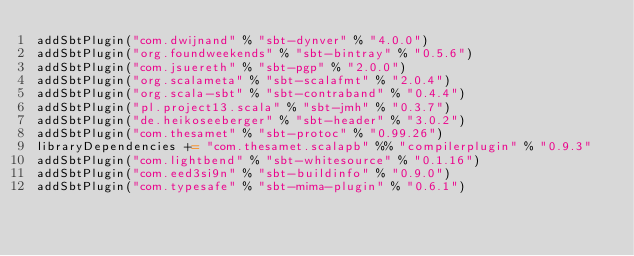Convert code to text. <code><loc_0><loc_0><loc_500><loc_500><_Scala_>addSbtPlugin("com.dwijnand" % "sbt-dynver" % "4.0.0")
addSbtPlugin("org.foundweekends" % "sbt-bintray" % "0.5.6")
addSbtPlugin("com.jsuereth" % "sbt-pgp" % "2.0.0")
addSbtPlugin("org.scalameta" % "sbt-scalafmt" % "2.0.4")
addSbtPlugin("org.scala-sbt" % "sbt-contraband" % "0.4.4")
addSbtPlugin("pl.project13.scala" % "sbt-jmh" % "0.3.7")
addSbtPlugin("de.heikoseeberger" % "sbt-header" % "3.0.2")
addSbtPlugin("com.thesamet" % "sbt-protoc" % "0.99.26")
libraryDependencies += "com.thesamet.scalapb" %% "compilerplugin" % "0.9.3"
addSbtPlugin("com.lightbend" % "sbt-whitesource" % "0.1.16")
addSbtPlugin("com.eed3si9n" % "sbt-buildinfo" % "0.9.0")
addSbtPlugin("com.typesafe" % "sbt-mima-plugin" % "0.6.1")
</code> 